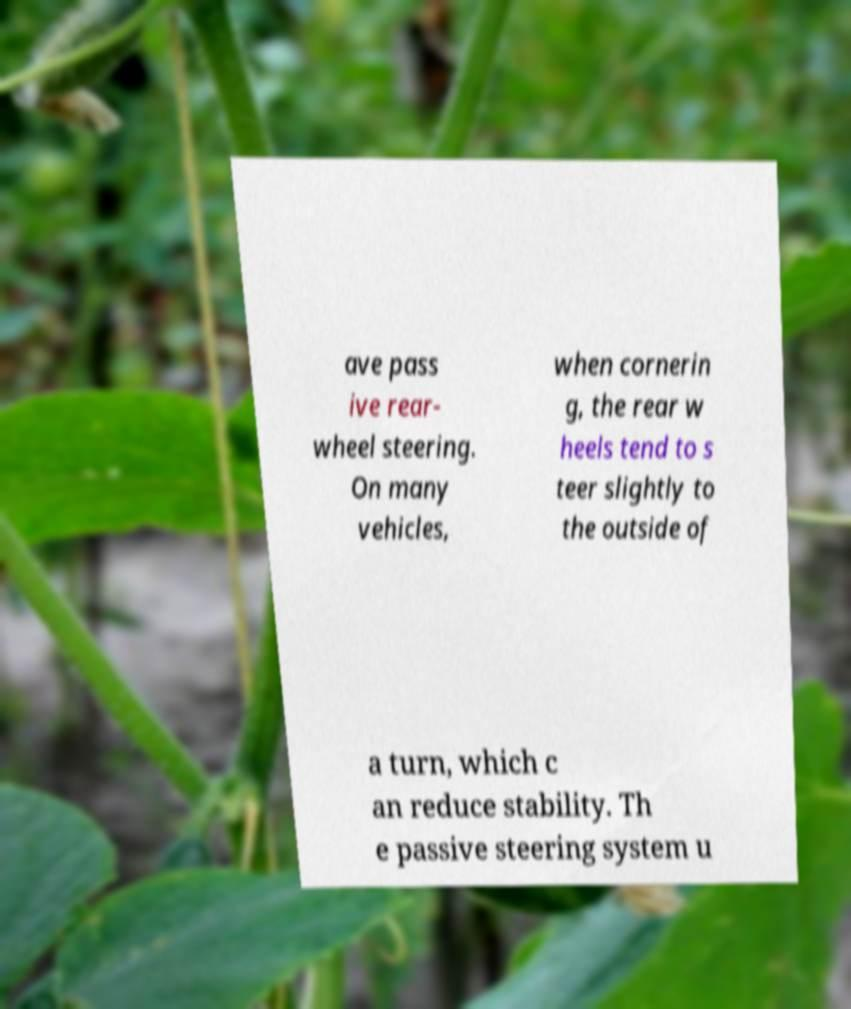Please identify and transcribe the text found in this image. ave pass ive rear- wheel steering. On many vehicles, when cornerin g, the rear w heels tend to s teer slightly to the outside of a turn, which c an reduce stability. Th e passive steering system u 